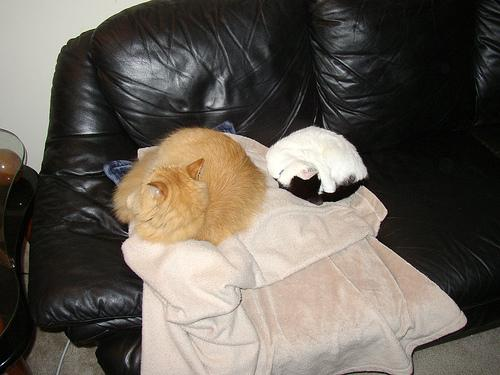Question: where is this picture taken?
Choices:
A. Bedroom.
B. By the couch.
C. On the bed.
D. A living room.
Answer with the letter. Answer: D Question: what animals are in the picture?
Choices:
A. A dog.
B. A pot bellied pig and a rooster.
C. Five mice.
D. Two cats.
Answer with the letter. Answer: D Question: what color are the cats?
Choices:
A. Brown.
B. Orange and white.
C. Black.
D. Gray.
Answer with the letter. Answer: B Question: what are the cats laying on?
Choices:
A. A bed.
B. A blanket.
C. Couch.
D. Vent.
Answer with the letter. Answer: B Question: what color is the blanket?
Choices:
A. Tan.
B. Black.
C. Red.
D. Blue.
Answer with the letter. Answer: A Question: how are the cats heads positioned?
Choices:
A. Tucked under.
B. To the right.
C. Cuddling with each other.
D. Looking up.
Answer with the letter. Answer: A 